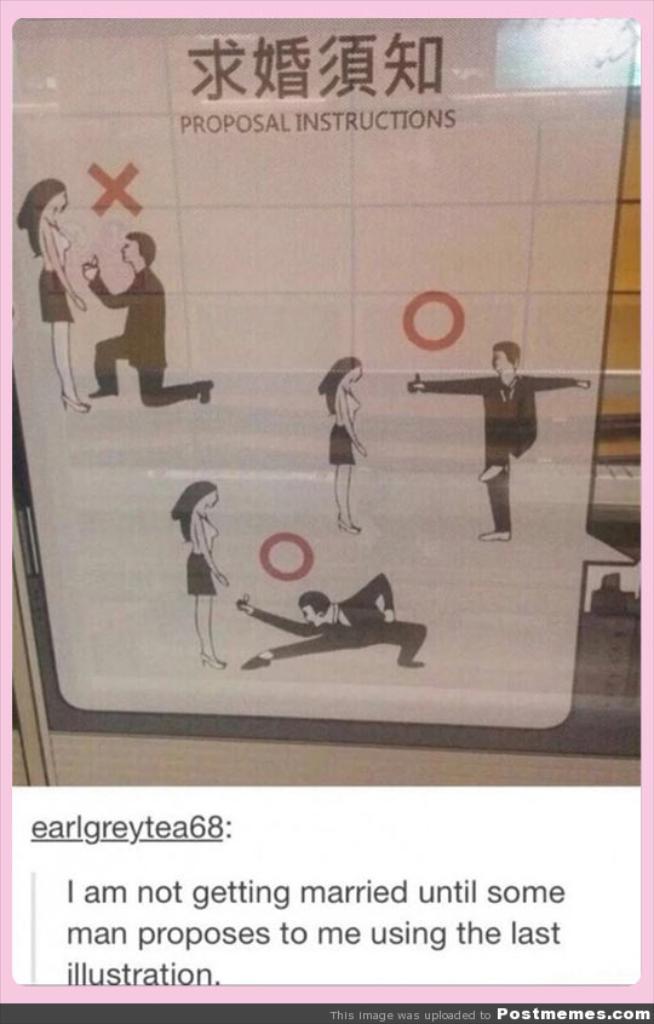<image>
Present a compact description of the photo's key features. A proposal instructional guide is commented on by a user called earlgreytea68. 